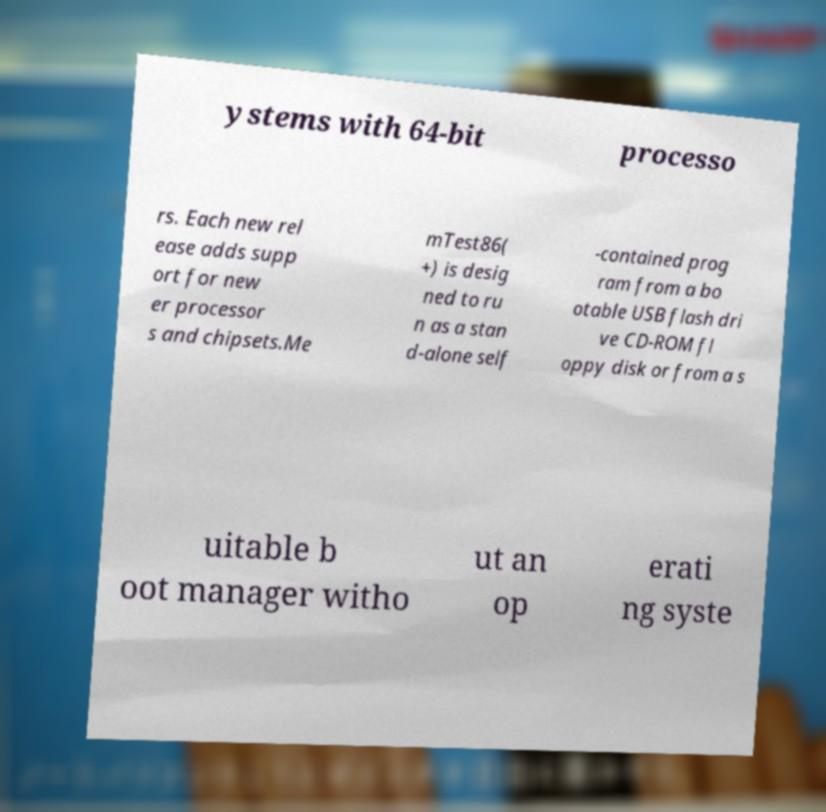For documentation purposes, I need the text within this image transcribed. Could you provide that? ystems with 64-bit processo rs. Each new rel ease adds supp ort for new er processor s and chipsets.Me mTest86( +) is desig ned to ru n as a stan d-alone self -contained prog ram from a bo otable USB flash dri ve CD-ROM fl oppy disk or from a s uitable b oot manager witho ut an op erati ng syste 